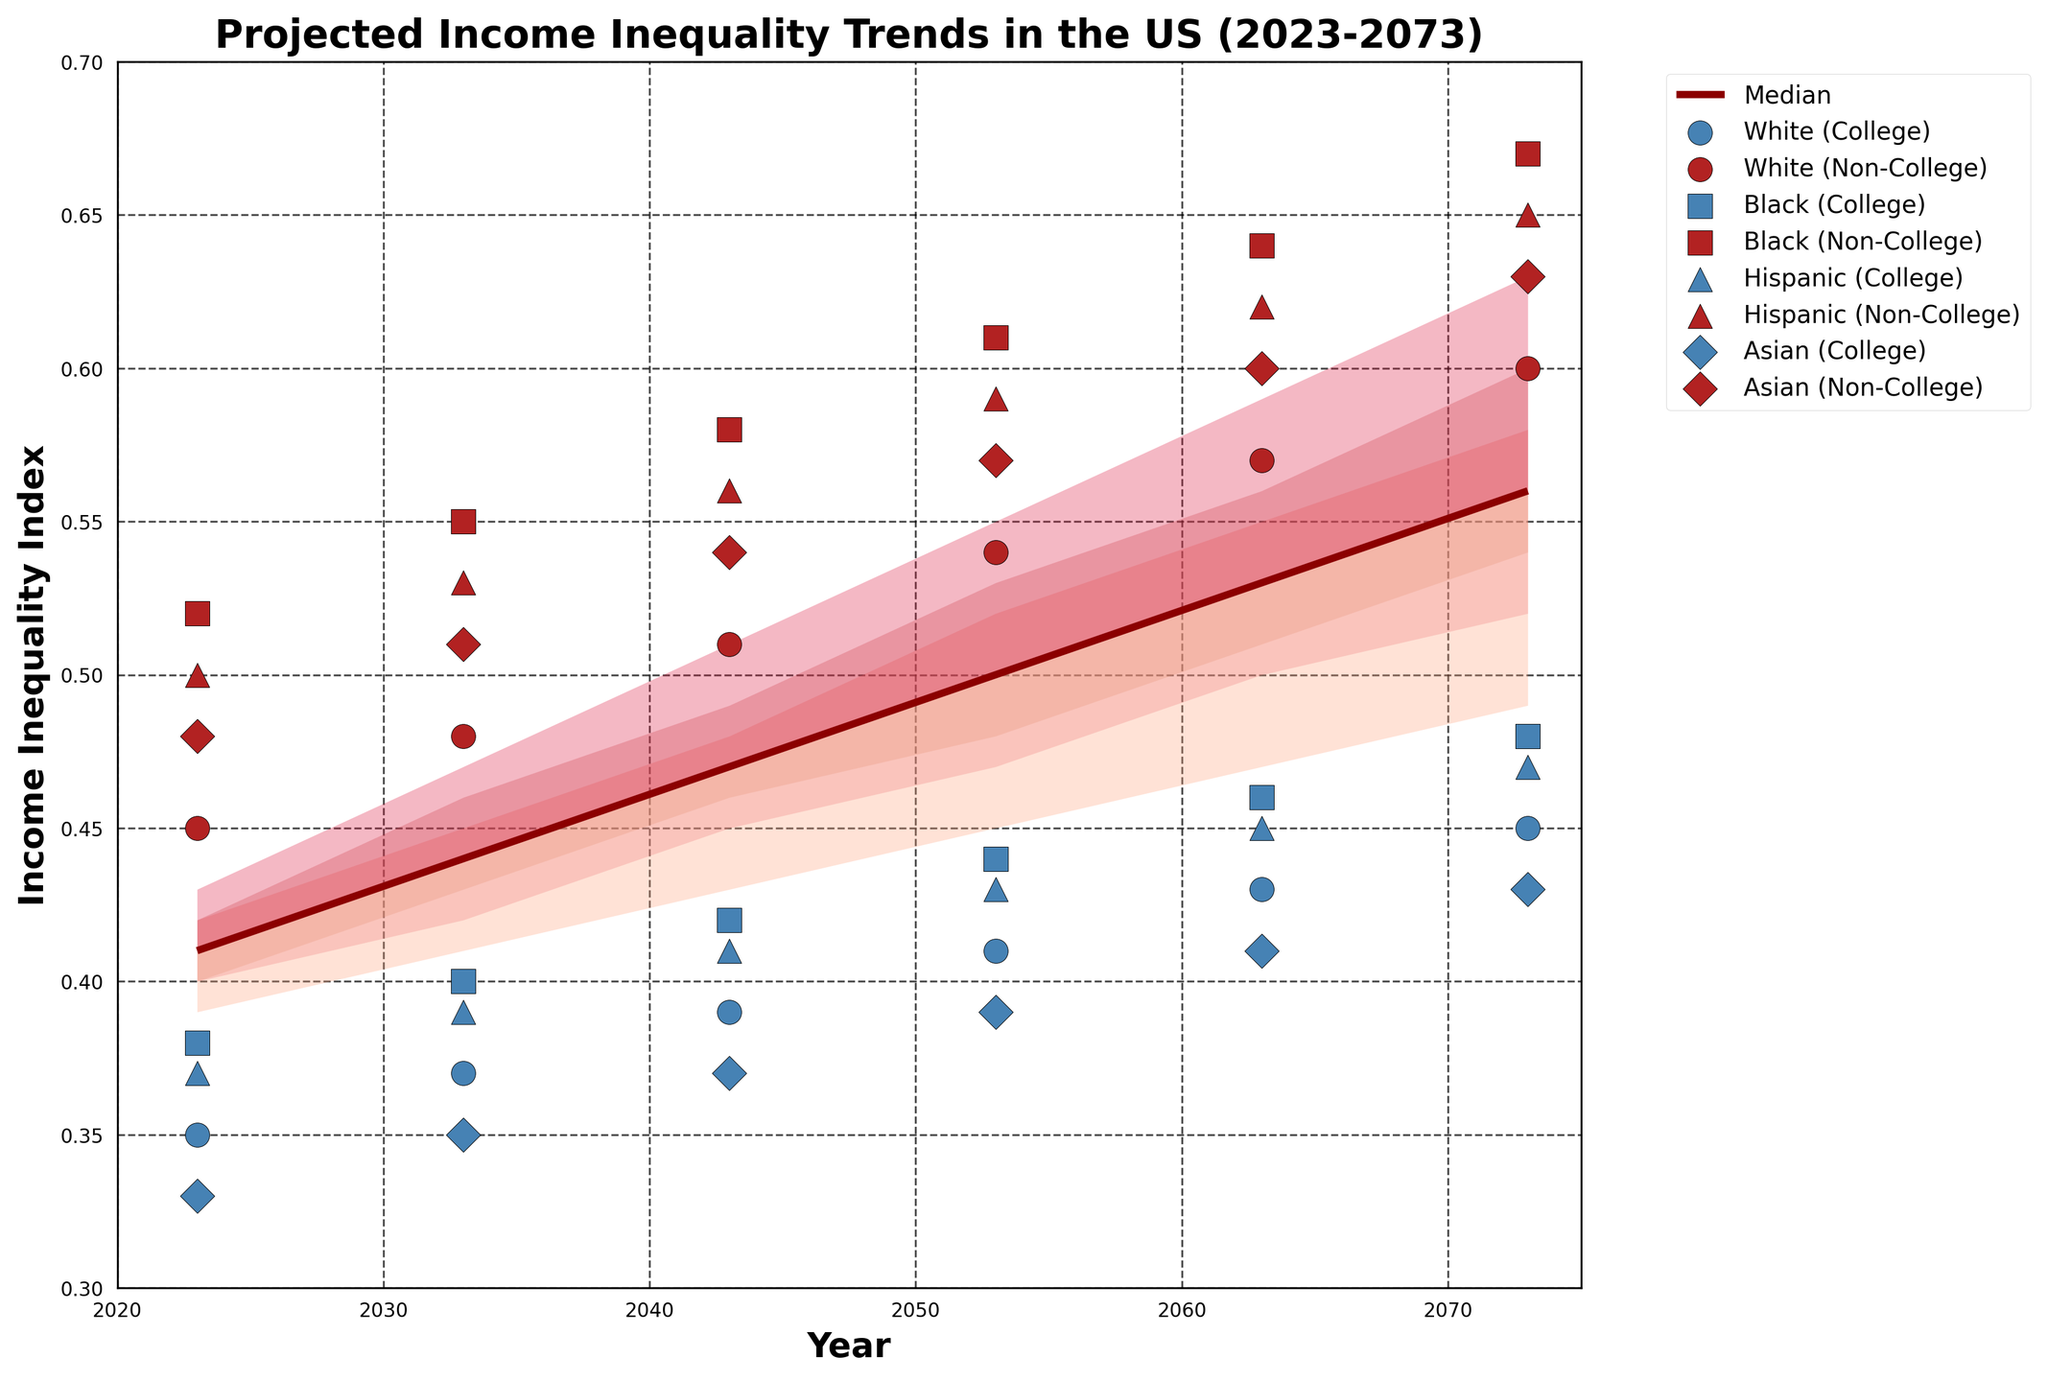What is the title of the figure? The title is usually displayed at the top of the figure, often in a larger and bold font.
Answer: Projected Income Inequality Trends in the US (2023-2073) What are the x-axis and y-axis labels of the figure? The axis labels are generally located near the axis lines, describing what each axis represents. The x-axis label is typically below the horizontal axis, and the y-axis label is beside the vertical axis.
Answer: The x-axis is labeled 'Year' and the y-axis is labeled 'Income Inequality Index' How does the median income inequality trend from 2023 to 2073? The median trend is shown as a line plot on the figure. Observing the points along the line plot from 2023 to 2073 shows whether it is increasing or decreasing.
Answer: It trends upward What is the general trend for income inequality for White (College) individuals between 2023 and 2073? The data points for each group are shown as scatter plots with different markers. Trace the points for White (College) individuals from 2023 to 2073.
Answer: It increases Which racial group with a college education has the highest income inequality in 2073? Locate the scatter points for 2073 and compare the values among the racial groups with a college education.
Answer: Black (College) How does the income inequality of White (Non-College) individuals compare to Hispanic (Non-College) individuals in 2053? Identify the scatter points for White (Non-College) and Hispanic (Non-College) in 2053 and compare the values.
Answer: Higher for White (Non-College) What is the income inequality index for Black (Non-College) individuals in 2043? Find the scatter plot point corresponding to Black (Non-College) for the year 2043.
Answer: 0.58 Between which years does the median income inequality cross 0.50? Observe the line plot corresponding to the median and identify the years between which it crosses the 0.50 mark.
Answer: Between 2043 and 2053 By how much does the income inequality index increase for Hispanic (Non-College) individuals from 2023 to 2073? Subtract the 2023 value of Hispanic (Non-College) from the 2073 value.
Answer: 0.63 - 0.50 = 0.13 What is the range of the high 10th percentile in 2063? The high 10th percentile for 2063 is shown as one of the upper bands. Find the value for the year 2063.
Answer: 0.59 Which group is projected to have the highest increase in income inequality from 2023 to 2073? Compare the values for each group between 2023 and 2073 and find the group with the highest difference.
Answer: Black (College) 